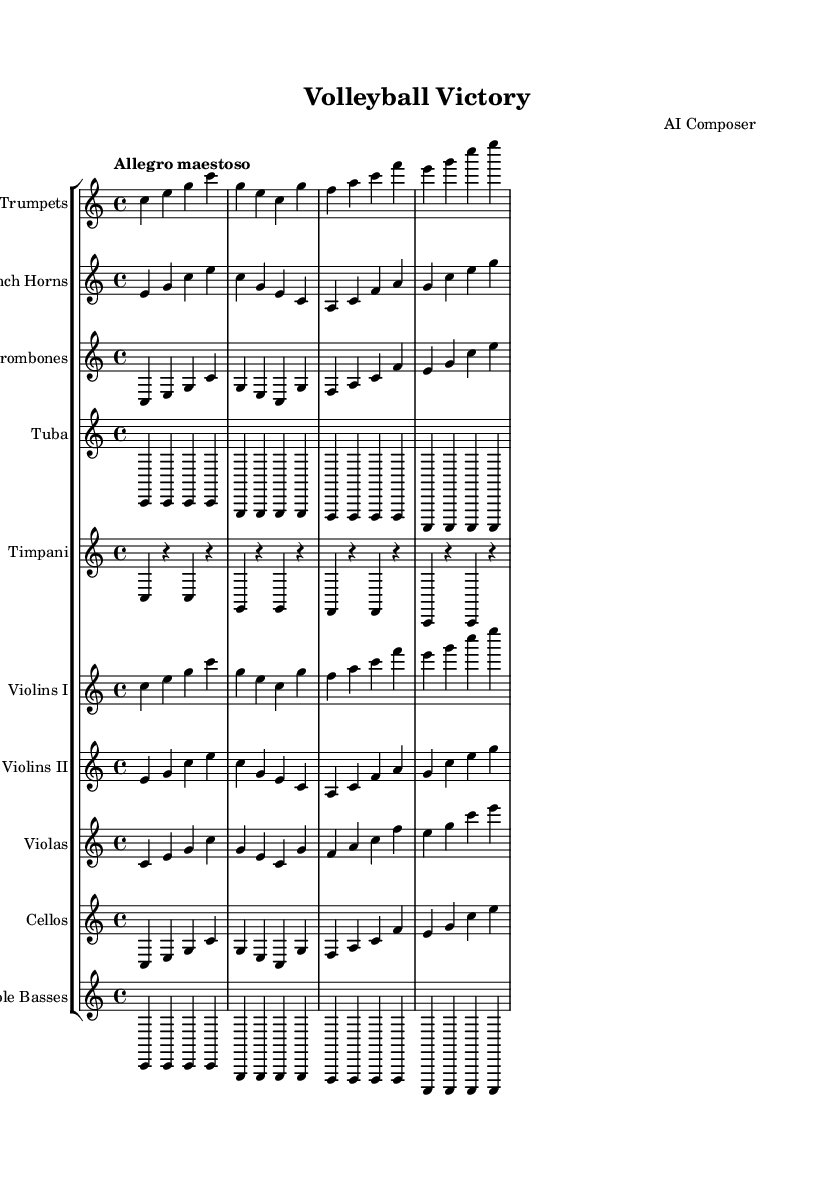What is the title of this piece? The title is indicated at the top of the sheet music as "Volleyball Victory".
Answer: Volleyball Victory What is the tempo marking for the piece? The tempo marking is found just above the staff and is indicated as "Allegro maestoso".
Answer: Allegro maestoso What is the time signature of the music? The time signature is shown at the beginning of the score and is indicated as 4/4, meaning there are four beats in each measure.
Answer: 4/4 Which instrument plays the melody in the first four measures? The first four measures feature primarily the trumpets playing the melody with clear notes.
Answer: Trumpets How many instrument groups are present in the score? The score includes a total of ten different instrument groups, as shown in the staff group notation.
Answer: Ten What is the key signature of this piece? The key signature is determined from the beginning of the score, which is in C major, indicated by no sharps or flats.
Answer: C major In which octave do the violas primarily play in this score? The violas are notated in the octave starting around middle C, specifically below the treble clef, typically in the C' octave, but also encroaching on the B' note values within the score context.
Answer: C 